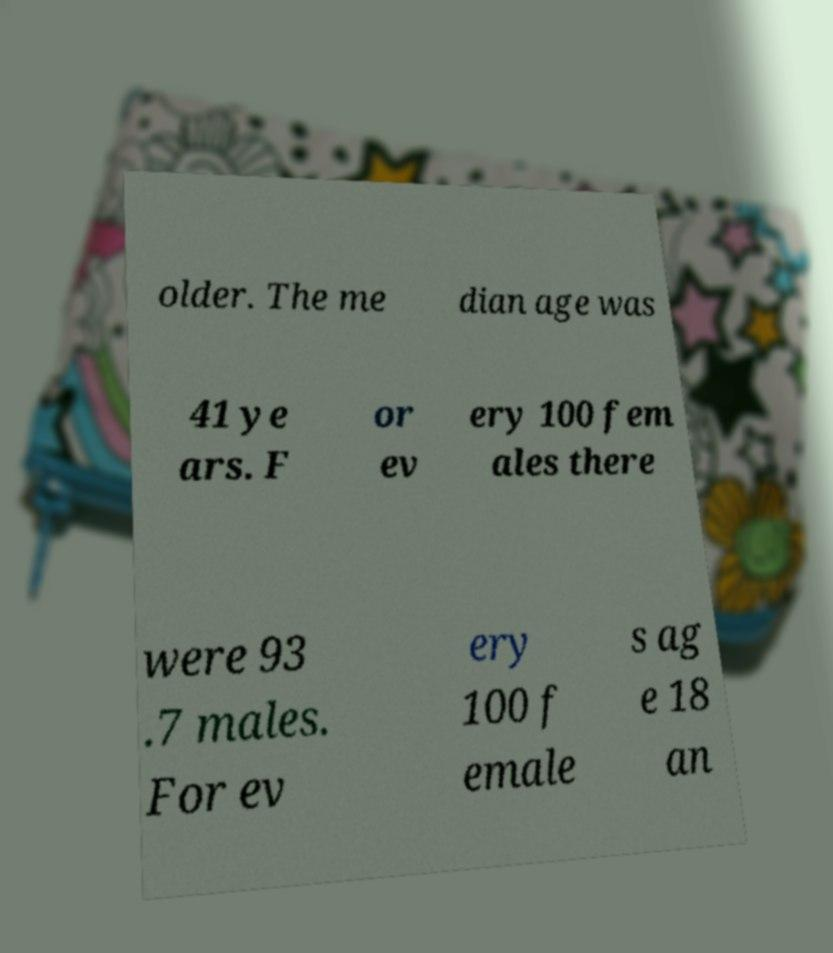Can you accurately transcribe the text from the provided image for me? older. The me dian age was 41 ye ars. F or ev ery 100 fem ales there were 93 .7 males. For ev ery 100 f emale s ag e 18 an 